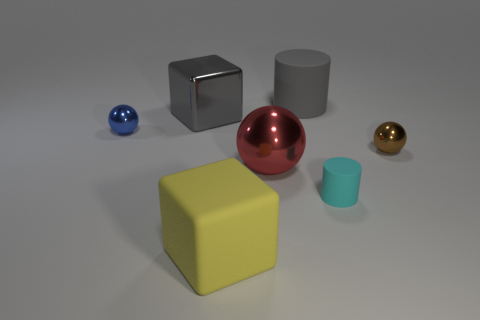Add 2 small rubber objects. How many objects exist? 9 Subtract all cylinders. How many objects are left? 5 Subtract all rubber cylinders. Subtract all large metallic spheres. How many objects are left? 4 Add 7 small blue spheres. How many small blue spheres are left? 8 Add 2 cyan cylinders. How many cyan cylinders exist? 3 Subtract 0 blue cylinders. How many objects are left? 7 